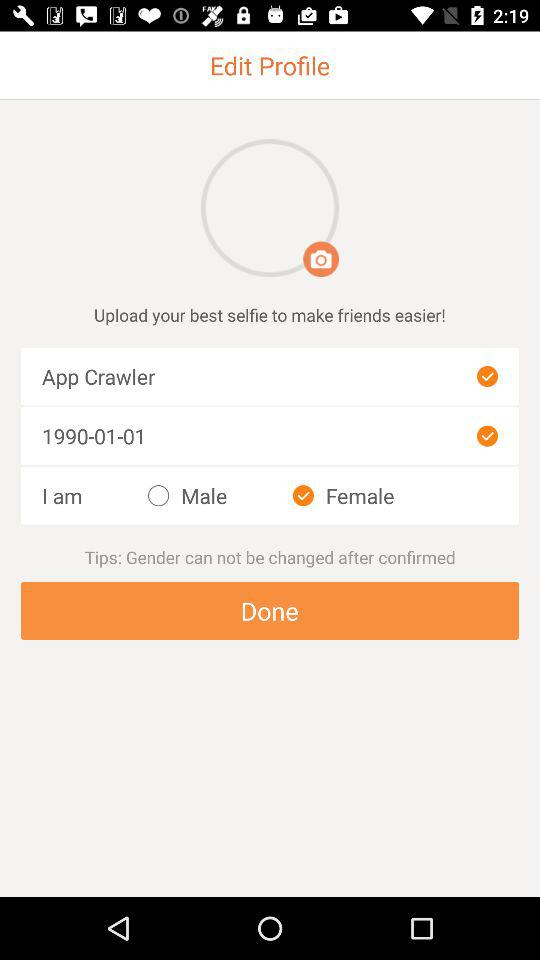Which image is the best selfie?
When the provided information is insufficient, respond with <no answer>. <no answer> 